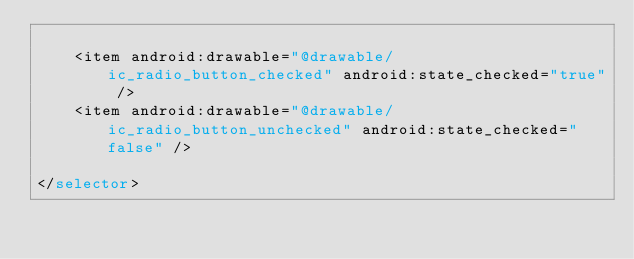<code> <loc_0><loc_0><loc_500><loc_500><_XML_>
    <item android:drawable="@drawable/ic_radio_button_checked" android:state_checked="true" />
    <item android:drawable="@drawable/ic_radio_button_unchecked" android:state_checked="false" />

</selector></code> 